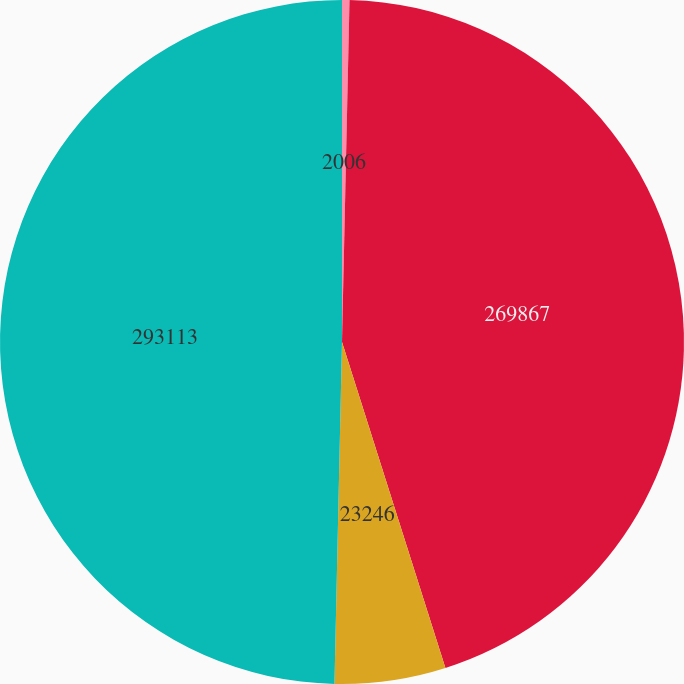Convert chart. <chart><loc_0><loc_0><loc_500><loc_500><pie_chart><fcel>2006<fcel>269867<fcel>23246<fcel>293113<nl><fcel>0.35%<fcel>44.76%<fcel>5.24%<fcel>49.65%<nl></chart> 